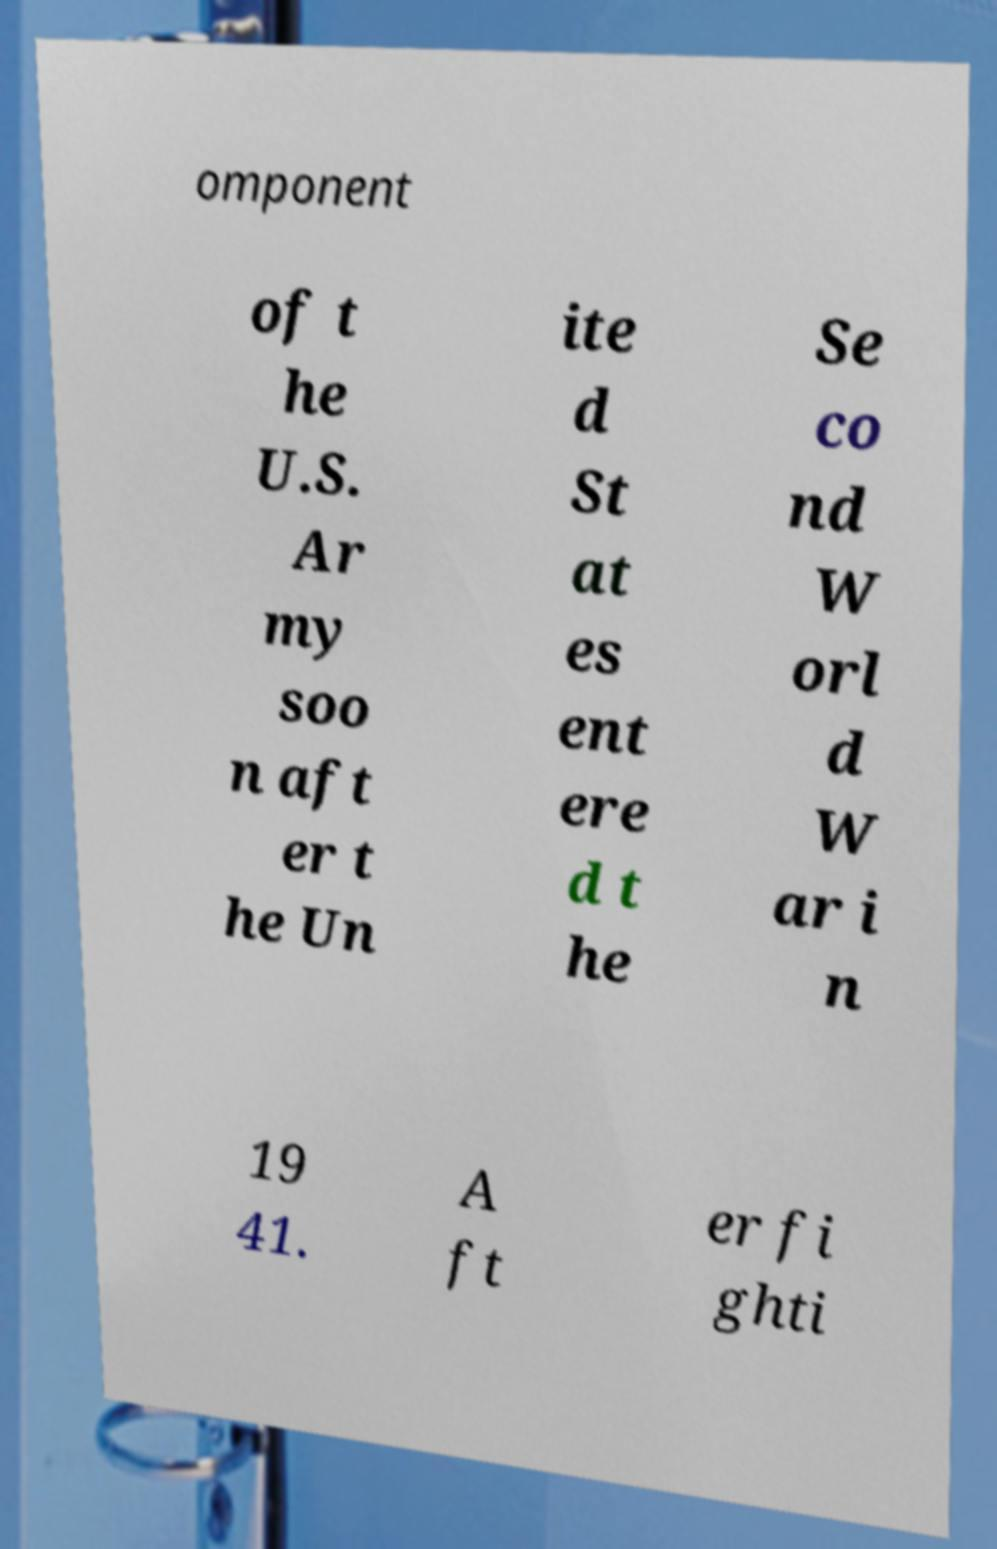I need the written content from this picture converted into text. Can you do that? omponent of t he U.S. Ar my soo n aft er t he Un ite d St at es ent ere d t he Se co nd W orl d W ar i n 19 41. A ft er fi ghti 